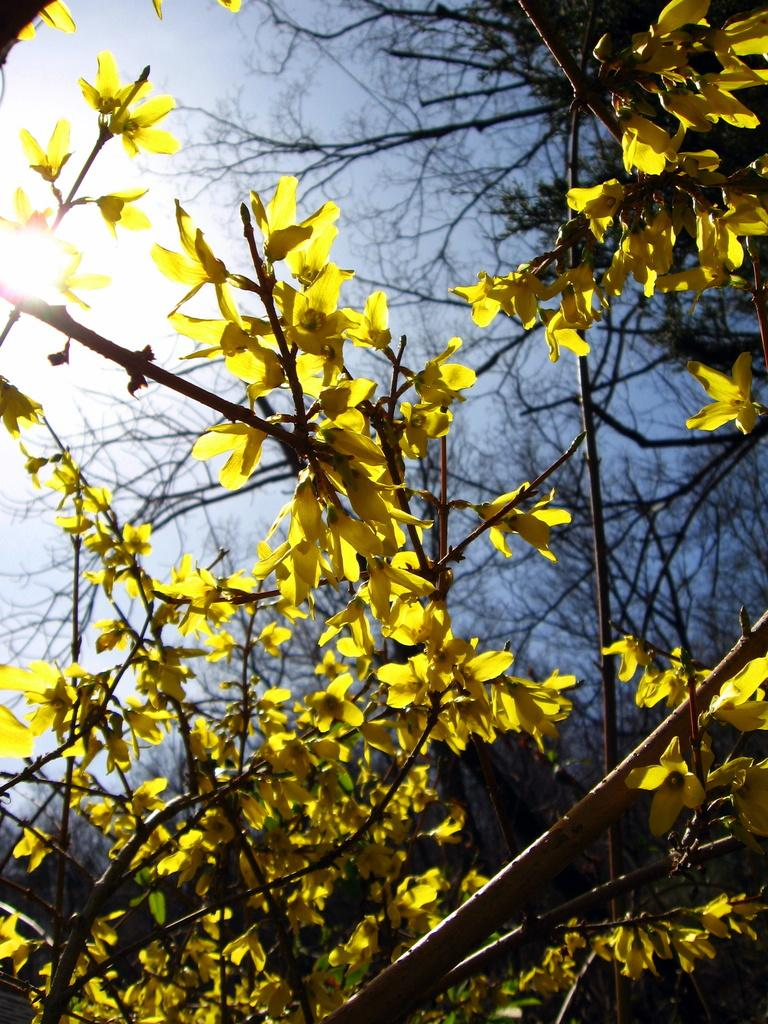What type of flowers can be seen on the plant in the image? There are yellow flowers on a plant in the image. What can be seen in the background of the image? There are trees in the background of the image. What celestial body is visible in the image? The sun is visible in the image. What is the color of the sky in the image? The sky is pale blue in color. Where is the throne located in the image? There is no throne present in the image. What type of lamp can be seen illuminating the flowers in the image? There is no lamp present in the image; the flowers are illuminated by natural sunlight. 